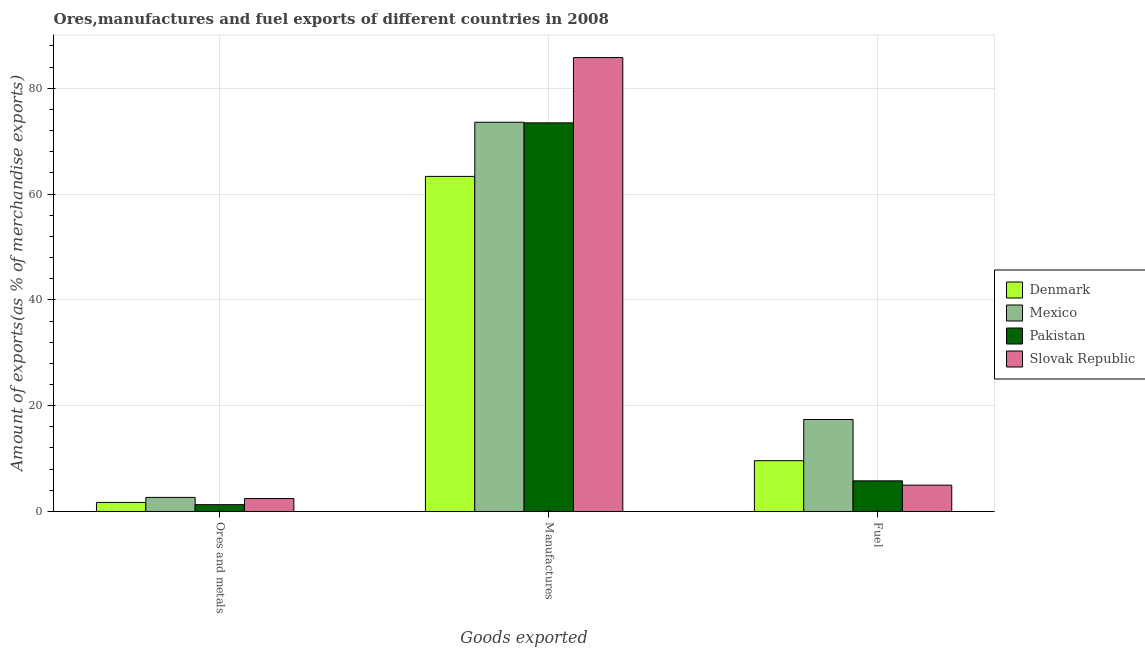How many bars are there on the 1st tick from the left?
Your response must be concise. 4. What is the label of the 3rd group of bars from the left?
Your response must be concise. Fuel. What is the percentage of manufactures exports in Mexico?
Your answer should be very brief. 73.57. Across all countries, what is the maximum percentage of ores and metals exports?
Offer a very short reply. 2.66. Across all countries, what is the minimum percentage of fuel exports?
Your response must be concise. 4.98. In which country was the percentage of ores and metals exports maximum?
Provide a succinct answer. Mexico. What is the total percentage of manufactures exports in the graph?
Provide a short and direct response. 296.15. What is the difference between the percentage of ores and metals exports in Slovak Republic and that in Denmark?
Keep it short and to the point. 0.74. What is the difference between the percentage of ores and metals exports in Mexico and the percentage of manufactures exports in Slovak Republic?
Offer a very short reply. -83.13. What is the average percentage of manufactures exports per country?
Keep it short and to the point. 74.04. What is the difference between the percentage of manufactures exports and percentage of fuel exports in Denmark?
Ensure brevity in your answer.  53.73. In how many countries, is the percentage of fuel exports greater than 44 %?
Ensure brevity in your answer.  0. What is the ratio of the percentage of ores and metals exports in Slovak Republic to that in Mexico?
Keep it short and to the point. 0.92. Is the percentage of manufactures exports in Slovak Republic less than that in Pakistan?
Provide a succinct answer. No. Is the difference between the percentage of fuel exports in Slovak Republic and Mexico greater than the difference between the percentage of manufactures exports in Slovak Republic and Mexico?
Your answer should be very brief. No. What is the difference between the highest and the second highest percentage of fuel exports?
Offer a terse response. 7.79. What is the difference between the highest and the lowest percentage of ores and metals exports?
Make the answer very short. 1.37. Is the sum of the percentage of fuel exports in Slovak Republic and Denmark greater than the maximum percentage of ores and metals exports across all countries?
Provide a succinct answer. Yes. What does the 4th bar from the left in Manufactures represents?
Make the answer very short. Slovak Republic. What does the 4th bar from the right in Fuel represents?
Your answer should be compact. Denmark. How many countries are there in the graph?
Provide a succinct answer. 4. Where does the legend appear in the graph?
Offer a terse response. Center right. How are the legend labels stacked?
Offer a terse response. Vertical. What is the title of the graph?
Provide a succinct answer. Ores,manufactures and fuel exports of different countries in 2008. What is the label or title of the X-axis?
Ensure brevity in your answer.  Goods exported. What is the label or title of the Y-axis?
Give a very brief answer. Amount of exports(as % of merchandise exports). What is the Amount of exports(as % of merchandise exports) in Denmark in Ores and metals?
Provide a short and direct response. 1.71. What is the Amount of exports(as % of merchandise exports) of Mexico in Ores and metals?
Your response must be concise. 2.66. What is the Amount of exports(as % of merchandise exports) in Pakistan in Ores and metals?
Offer a very short reply. 1.29. What is the Amount of exports(as % of merchandise exports) in Slovak Republic in Ores and metals?
Keep it short and to the point. 2.45. What is the Amount of exports(as % of merchandise exports) of Denmark in Manufactures?
Give a very brief answer. 63.34. What is the Amount of exports(as % of merchandise exports) of Mexico in Manufactures?
Your answer should be compact. 73.57. What is the Amount of exports(as % of merchandise exports) of Pakistan in Manufactures?
Keep it short and to the point. 73.45. What is the Amount of exports(as % of merchandise exports) in Slovak Republic in Manufactures?
Offer a very short reply. 85.79. What is the Amount of exports(as % of merchandise exports) of Denmark in Fuel?
Your answer should be very brief. 9.6. What is the Amount of exports(as % of merchandise exports) in Mexico in Fuel?
Keep it short and to the point. 17.39. What is the Amount of exports(as % of merchandise exports) of Pakistan in Fuel?
Your answer should be very brief. 5.79. What is the Amount of exports(as % of merchandise exports) of Slovak Republic in Fuel?
Provide a succinct answer. 4.98. Across all Goods exported, what is the maximum Amount of exports(as % of merchandise exports) of Denmark?
Your answer should be very brief. 63.34. Across all Goods exported, what is the maximum Amount of exports(as % of merchandise exports) in Mexico?
Offer a very short reply. 73.57. Across all Goods exported, what is the maximum Amount of exports(as % of merchandise exports) in Pakistan?
Provide a succinct answer. 73.45. Across all Goods exported, what is the maximum Amount of exports(as % of merchandise exports) in Slovak Republic?
Provide a short and direct response. 85.79. Across all Goods exported, what is the minimum Amount of exports(as % of merchandise exports) in Denmark?
Provide a succinct answer. 1.71. Across all Goods exported, what is the minimum Amount of exports(as % of merchandise exports) in Mexico?
Keep it short and to the point. 2.66. Across all Goods exported, what is the minimum Amount of exports(as % of merchandise exports) of Pakistan?
Give a very brief answer. 1.29. Across all Goods exported, what is the minimum Amount of exports(as % of merchandise exports) of Slovak Republic?
Your answer should be compact. 2.45. What is the total Amount of exports(as % of merchandise exports) in Denmark in the graph?
Your response must be concise. 74.65. What is the total Amount of exports(as % of merchandise exports) of Mexico in the graph?
Your answer should be compact. 93.62. What is the total Amount of exports(as % of merchandise exports) in Pakistan in the graph?
Offer a terse response. 80.54. What is the total Amount of exports(as % of merchandise exports) of Slovak Republic in the graph?
Give a very brief answer. 93.22. What is the difference between the Amount of exports(as % of merchandise exports) of Denmark in Ores and metals and that in Manufactures?
Offer a very short reply. -61.62. What is the difference between the Amount of exports(as % of merchandise exports) of Mexico in Ores and metals and that in Manufactures?
Offer a terse response. -70.91. What is the difference between the Amount of exports(as % of merchandise exports) in Pakistan in Ores and metals and that in Manufactures?
Give a very brief answer. -72.16. What is the difference between the Amount of exports(as % of merchandise exports) of Slovak Republic in Ores and metals and that in Manufactures?
Your response must be concise. -83.35. What is the difference between the Amount of exports(as % of merchandise exports) in Denmark in Ores and metals and that in Fuel?
Provide a short and direct response. -7.89. What is the difference between the Amount of exports(as % of merchandise exports) of Mexico in Ores and metals and that in Fuel?
Give a very brief answer. -14.72. What is the difference between the Amount of exports(as % of merchandise exports) in Pakistan in Ores and metals and that in Fuel?
Provide a succinct answer. -4.5. What is the difference between the Amount of exports(as % of merchandise exports) of Slovak Republic in Ores and metals and that in Fuel?
Your answer should be very brief. -2.53. What is the difference between the Amount of exports(as % of merchandise exports) of Denmark in Manufactures and that in Fuel?
Ensure brevity in your answer.  53.73. What is the difference between the Amount of exports(as % of merchandise exports) of Mexico in Manufactures and that in Fuel?
Make the answer very short. 56.18. What is the difference between the Amount of exports(as % of merchandise exports) in Pakistan in Manufactures and that in Fuel?
Your answer should be compact. 67.66. What is the difference between the Amount of exports(as % of merchandise exports) of Slovak Republic in Manufactures and that in Fuel?
Offer a terse response. 80.81. What is the difference between the Amount of exports(as % of merchandise exports) of Denmark in Ores and metals and the Amount of exports(as % of merchandise exports) of Mexico in Manufactures?
Offer a terse response. -71.86. What is the difference between the Amount of exports(as % of merchandise exports) of Denmark in Ores and metals and the Amount of exports(as % of merchandise exports) of Pakistan in Manufactures?
Give a very brief answer. -71.74. What is the difference between the Amount of exports(as % of merchandise exports) of Denmark in Ores and metals and the Amount of exports(as % of merchandise exports) of Slovak Republic in Manufactures?
Provide a short and direct response. -84.08. What is the difference between the Amount of exports(as % of merchandise exports) of Mexico in Ores and metals and the Amount of exports(as % of merchandise exports) of Pakistan in Manufactures?
Offer a terse response. -70.79. What is the difference between the Amount of exports(as % of merchandise exports) in Mexico in Ores and metals and the Amount of exports(as % of merchandise exports) in Slovak Republic in Manufactures?
Give a very brief answer. -83.13. What is the difference between the Amount of exports(as % of merchandise exports) of Pakistan in Ores and metals and the Amount of exports(as % of merchandise exports) of Slovak Republic in Manufactures?
Offer a terse response. -84.51. What is the difference between the Amount of exports(as % of merchandise exports) in Denmark in Ores and metals and the Amount of exports(as % of merchandise exports) in Mexico in Fuel?
Your response must be concise. -15.68. What is the difference between the Amount of exports(as % of merchandise exports) of Denmark in Ores and metals and the Amount of exports(as % of merchandise exports) of Pakistan in Fuel?
Your answer should be compact. -4.08. What is the difference between the Amount of exports(as % of merchandise exports) of Denmark in Ores and metals and the Amount of exports(as % of merchandise exports) of Slovak Republic in Fuel?
Your response must be concise. -3.27. What is the difference between the Amount of exports(as % of merchandise exports) of Mexico in Ores and metals and the Amount of exports(as % of merchandise exports) of Pakistan in Fuel?
Ensure brevity in your answer.  -3.13. What is the difference between the Amount of exports(as % of merchandise exports) in Mexico in Ores and metals and the Amount of exports(as % of merchandise exports) in Slovak Republic in Fuel?
Ensure brevity in your answer.  -2.32. What is the difference between the Amount of exports(as % of merchandise exports) in Pakistan in Ores and metals and the Amount of exports(as % of merchandise exports) in Slovak Republic in Fuel?
Provide a succinct answer. -3.69. What is the difference between the Amount of exports(as % of merchandise exports) in Denmark in Manufactures and the Amount of exports(as % of merchandise exports) in Mexico in Fuel?
Your response must be concise. 45.95. What is the difference between the Amount of exports(as % of merchandise exports) of Denmark in Manufactures and the Amount of exports(as % of merchandise exports) of Pakistan in Fuel?
Your answer should be compact. 57.54. What is the difference between the Amount of exports(as % of merchandise exports) in Denmark in Manufactures and the Amount of exports(as % of merchandise exports) in Slovak Republic in Fuel?
Provide a short and direct response. 58.36. What is the difference between the Amount of exports(as % of merchandise exports) in Mexico in Manufactures and the Amount of exports(as % of merchandise exports) in Pakistan in Fuel?
Ensure brevity in your answer.  67.78. What is the difference between the Amount of exports(as % of merchandise exports) in Mexico in Manufactures and the Amount of exports(as % of merchandise exports) in Slovak Republic in Fuel?
Provide a short and direct response. 68.59. What is the difference between the Amount of exports(as % of merchandise exports) in Pakistan in Manufactures and the Amount of exports(as % of merchandise exports) in Slovak Republic in Fuel?
Your answer should be very brief. 68.47. What is the average Amount of exports(as % of merchandise exports) in Denmark per Goods exported?
Offer a terse response. 24.88. What is the average Amount of exports(as % of merchandise exports) of Mexico per Goods exported?
Make the answer very short. 31.21. What is the average Amount of exports(as % of merchandise exports) of Pakistan per Goods exported?
Offer a terse response. 26.85. What is the average Amount of exports(as % of merchandise exports) of Slovak Republic per Goods exported?
Offer a very short reply. 31.07. What is the difference between the Amount of exports(as % of merchandise exports) of Denmark and Amount of exports(as % of merchandise exports) of Mexico in Ores and metals?
Your answer should be very brief. -0.95. What is the difference between the Amount of exports(as % of merchandise exports) of Denmark and Amount of exports(as % of merchandise exports) of Pakistan in Ores and metals?
Your response must be concise. 0.42. What is the difference between the Amount of exports(as % of merchandise exports) of Denmark and Amount of exports(as % of merchandise exports) of Slovak Republic in Ores and metals?
Provide a succinct answer. -0.74. What is the difference between the Amount of exports(as % of merchandise exports) of Mexico and Amount of exports(as % of merchandise exports) of Pakistan in Ores and metals?
Your response must be concise. 1.37. What is the difference between the Amount of exports(as % of merchandise exports) of Mexico and Amount of exports(as % of merchandise exports) of Slovak Republic in Ores and metals?
Provide a short and direct response. 0.22. What is the difference between the Amount of exports(as % of merchandise exports) of Pakistan and Amount of exports(as % of merchandise exports) of Slovak Republic in Ores and metals?
Your answer should be very brief. -1.16. What is the difference between the Amount of exports(as % of merchandise exports) of Denmark and Amount of exports(as % of merchandise exports) of Mexico in Manufactures?
Provide a short and direct response. -10.24. What is the difference between the Amount of exports(as % of merchandise exports) of Denmark and Amount of exports(as % of merchandise exports) of Pakistan in Manufactures?
Provide a succinct answer. -10.12. What is the difference between the Amount of exports(as % of merchandise exports) in Denmark and Amount of exports(as % of merchandise exports) in Slovak Republic in Manufactures?
Ensure brevity in your answer.  -22.46. What is the difference between the Amount of exports(as % of merchandise exports) of Mexico and Amount of exports(as % of merchandise exports) of Pakistan in Manufactures?
Your response must be concise. 0.12. What is the difference between the Amount of exports(as % of merchandise exports) of Mexico and Amount of exports(as % of merchandise exports) of Slovak Republic in Manufactures?
Your response must be concise. -12.22. What is the difference between the Amount of exports(as % of merchandise exports) of Pakistan and Amount of exports(as % of merchandise exports) of Slovak Republic in Manufactures?
Give a very brief answer. -12.34. What is the difference between the Amount of exports(as % of merchandise exports) in Denmark and Amount of exports(as % of merchandise exports) in Mexico in Fuel?
Keep it short and to the point. -7.79. What is the difference between the Amount of exports(as % of merchandise exports) of Denmark and Amount of exports(as % of merchandise exports) of Pakistan in Fuel?
Offer a terse response. 3.81. What is the difference between the Amount of exports(as % of merchandise exports) in Denmark and Amount of exports(as % of merchandise exports) in Slovak Republic in Fuel?
Make the answer very short. 4.62. What is the difference between the Amount of exports(as % of merchandise exports) of Mexico and Amount of exports(as % of merchandise exports) of Pakistan in Fuel?
Ensure brevity in your answer.  11.59. What is the difference between the Amount of exports(as % of merchandise exports) in Mexico and Amount of exports(as % of merchandise exports) in Slovak Republic in Fuel?
Your answer should be very brief. 12.41. What is the difference between the Amount of exports(as % of merchandise exports) in Pakistan and Amount of exports(as % of merchandise exports) in Slovak Republic in Fuel?
Your answer should be very brief. 0.81. What is the ratio of the Amount of exports(as % of merchandise exports) of Denmark in Ores and metals to that in Manufactures?
Your response must be concise. 0.03. What is the ratio of the Amount of exports(as % of merchandise exports) of Mexico in Ores and metals to that in Manufactures?
Give a very brief answer. 0.04. What is the ratio of the Amount of exports(as % of merchandise exports) in Pakistan in Ores and metals to that in Manufactures?
Offer a very short reply. 0.02. What is the ratio of the Amount of exports(as % of merchandise exports) of Slovak Republic in Ores and metals to that in Manufactures?
Give a very brief answer. 0.03. What is the ratio of the Amount of exports(as % of merchandise exports) of Denmark in Ores and metals to that in Fuel?
Offer a terse response. 0.18. What is the ratio of the Amount of exports(as % of merchandise exports) in Mexico in Ores and metals to that in Fuel?
Your answer should be very brief. 0.15. What is the ratio of the Amount of exports(as % of merchandise exports) of Pakistan in Ores and metals to that in Fuel?
Provide a succinct answer. 0.22. What is the ratio of the Amount of exports(as % of merchandise exports) of Slovak Republic in Ores and metals to that in Fuel?
Ensure brevity in your answer.  0.49. What is the ratio of the Amount of exports(as % of merchandise exports) in Denmark in Manufactures to that in Fuel?
Ensure brevity in your answer.  6.6. What is the ratio of the Amount of exports(as % of merchandise exports) of Mexico in Manufactures to that in Fuel?
Your answer should be very brief. 4.23. What is the ratio of the Amount of exports(as % of merchandise exports) in Pakistan in Manufactures to that in Fuel?
Ensure brevity in your answer.  12.68. What is the ratio of the Amount of exports(as % of merchandise exports) of Slovak Republic in Manufactures to that in Fuel?
Your response must be concise. 17.23. What is the difference between the highest and the second highest Amount of exports(as % of merchandise exports) in Denmark?
Keep it short and to the point. 53.73. What is the difference between the highest and the second highest Amount of exports(as % of merchandise exports) of Mexico?
Ensure brevity in your answer.  56.18. What is the difference between the highest and the second highest Amount of exports(as % of merchandise exports) in Pakistan?
Provide a short and direct response. 67.66. What is the difference between the highest and the second highest Amount of exports(as % of merchandise exports) of Slovak Republic?
Offer a terse response. 80.81. What is the difference between the highest and the lowest Amount of exports(as % of merchandise exports) in Denmark?
Provide a succinct answer. 61.62. What is the difference between the highest and the lowest Amount of exports(as % of merchandise exports) in Mexico?
Provide a short and direct response. 70.91. What is the difference between the highest and the lowest Amount of exports(as % of merchandise exports) in Pakistan?
Ensure brevity in your answer.  72.16. What is the difference between the highest and the lowest Amount of exports(as % of merchandise exports) of Slovak Republic?
Offer a terse response. 83.35. 